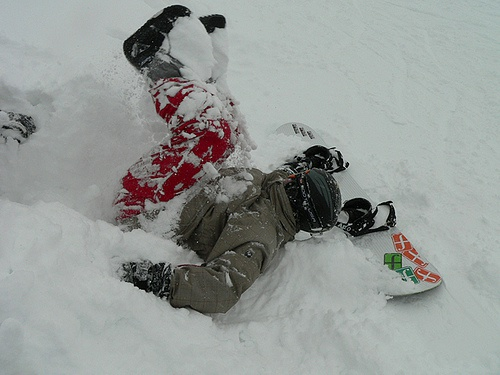Describe the objects in this image and their specific colors. I can see people in darkgray, black, gray, and maroon tones and snowboard in darkgray, gray, and brown tones in this image. 